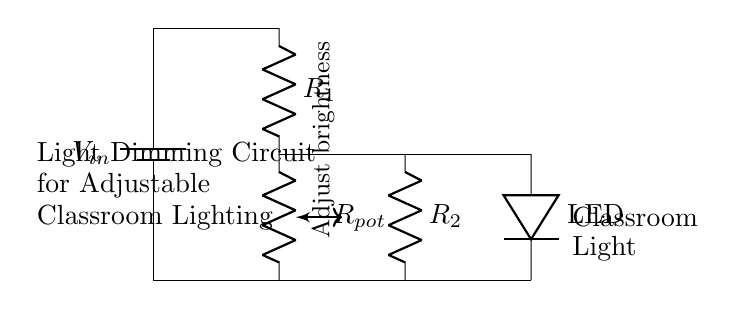What is the power source in this circuit? The power source in this circuit is the battery labeled as V_in, which provides the necessary voltage for the operation of the circuit components.
Answer: battery What component controls the brightness of the light? The component that controls the brightness of the light is the potentiometer labeled as R_pot, which allows the user to adjust the resistance in the circuit, thus varying the current through the LED.
Answer: potentiometer What type of light is being used in this circuit? The type of light used in this circuit is an LED (Light Emitting Diode), which is indicated by the label on the circuit.
Answer: LED What is the purpose of resistor R_1? Resistor R_1 is used to limit the current flowing through the circuit to prevent damage to the LED and ensure it operates within its rated specifications.
Answer: limit current Which components are connected in parallel? The components connected in parallel are R_2 and the LED, allowing them to share the same voltage while having different current paths.
Answer: R_2 and LED If the resistance of R_pot is increased, what happens to the light's brightness? If the resistance of R_pot is increased, the overall circuit resistance increases, reducing the current flowing through the LED, which results in dimmer light output.
Answer: dimmer 